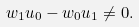Convert formula to latex. <formula><loc_0><loc_0><loc_500><loc_500>w _ { 1 } u _ { 0 } - w _ { 0 } u _ { 1 } \neq 0 .</formula> 